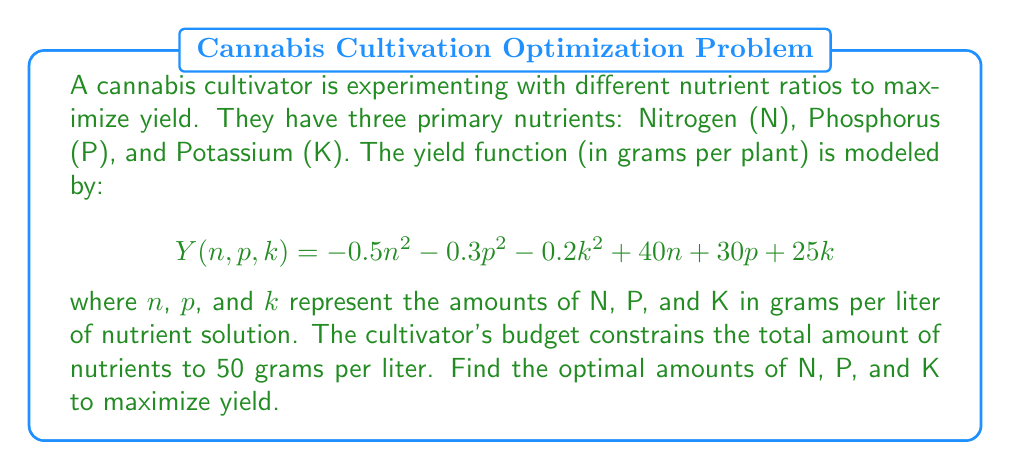Help me with this question. To solve this optimization problem, we'll use the method of Lagrange multipliers:

1) First, we set up the Lagrangian function:
   $$L(n,p,k,\lambda) = -0.5n^2 - 0.3p^2 - 0.2k^2 + 40n + 30p + 25k + \lambda(50 - n - p - k)$$

2) Now, we take partial derivatives and set them equal to zero:

   $$\frac{\partial L}{\partial n} = -n + 40 - \lambda = 0$$
   $$\frac{\partial L}{\partial p} = -0.6p + 30 - \lambda = 0$$
   $$\frac{\partial L}{\partial k} = -0.4k + 25 - \lambda = 0$$
   $$\frac{\partial L}{\partial \lambda} = 50 - n - p - k = 0$$

3) From these equations, we can derive:
   $$n = 40 - \lambda$$
   $$p = 50 - \frac{5}{3}\lambda$$
   $$k = 62.5 - \frac{5}{2}\lambda$$

4) Substituting these into the constraint equation:
   $$(40 - \lambda) + (50 - \frac{5}{3}\lambda) + (62.5 - \frac{5}{2}\lambda) = 50$$

5) Solving this equation:
   $$152.5 - \frac{25}{6}\lambda = 50$$
   $$\frac{25}{6}\lambda = 102.5$$
   $$\lambda = 24.6$$

6) Now we can find the optimal values:
   $$n = 40 - 24.6 = 15.4$$
   $$p = 50 - \frac{5}{3}(24.6) = 9.0$$
   $$k = 62.5 - \frac{5}{2}(24.6) = 25.6$$

7) We can verify that these sum to 50 grams as required by the constraint.
Answer: The optimal nutrient ratio to maximize yield is approximately 15.4 grams of Nitrogen, 9.0 grams of Phosphorus, and 25.6 grams of Potassium per liter of nutrient solution. 